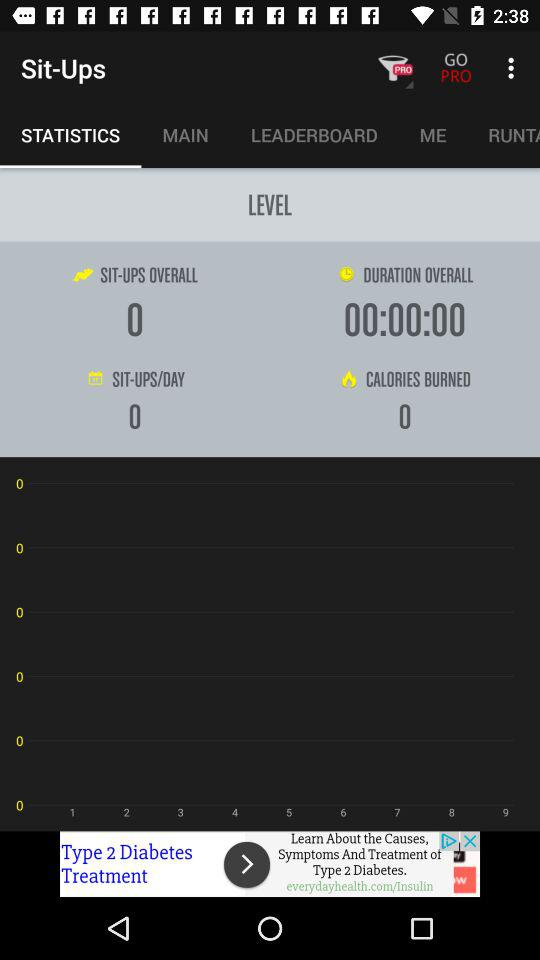How many calories are burned? The number of burned calories is 0. 